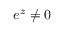Convert formula to latex. <formula><loc_0><loc_0><loc_500><loc_500>e ^ { z } \neq 0</formula> 